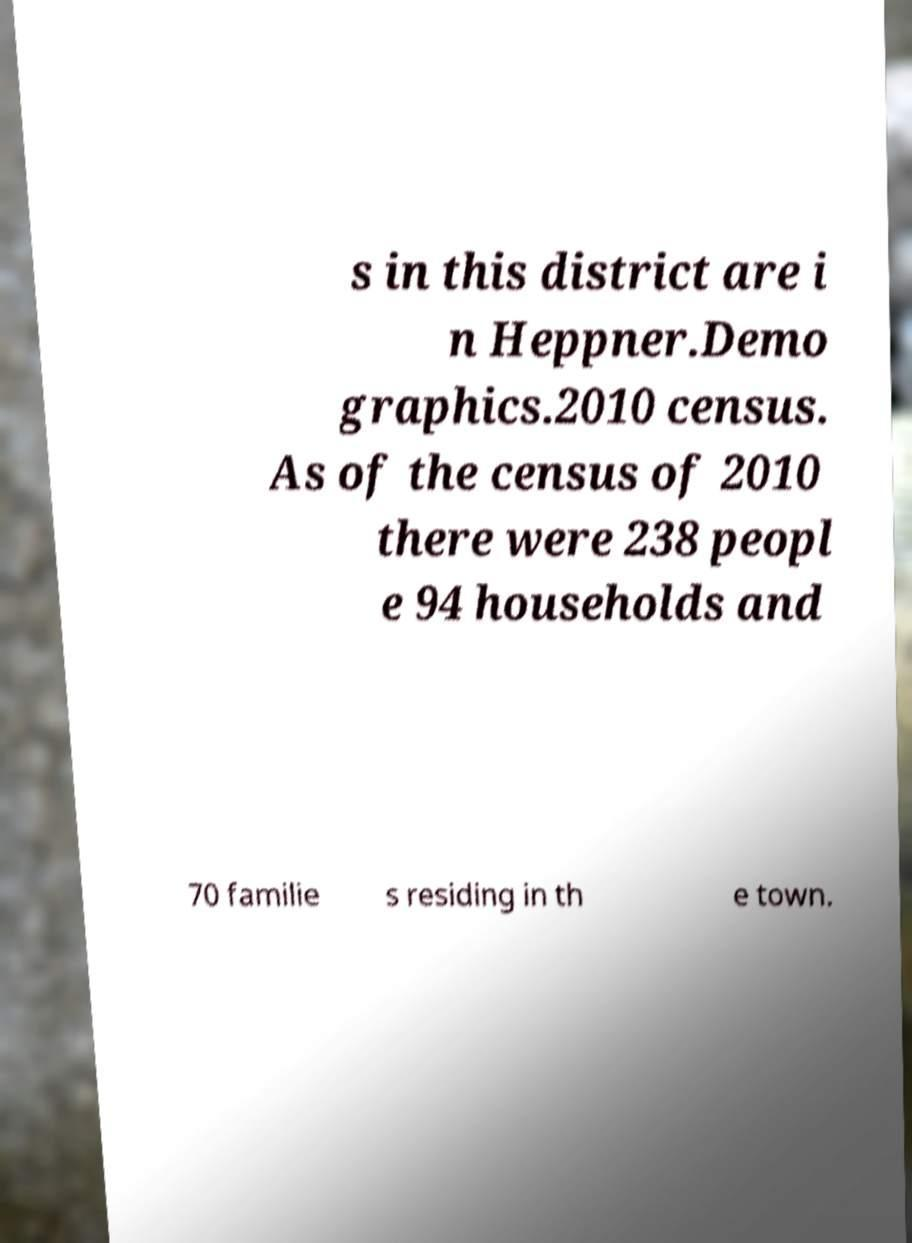Can you accurately transcribe the text from the provided image for me? s in this district are i n Heppner.Demo graphics.2010 census. As of the census of 2010 there were 238 peopl e 94 households and 70 familie s residing in th e town. 